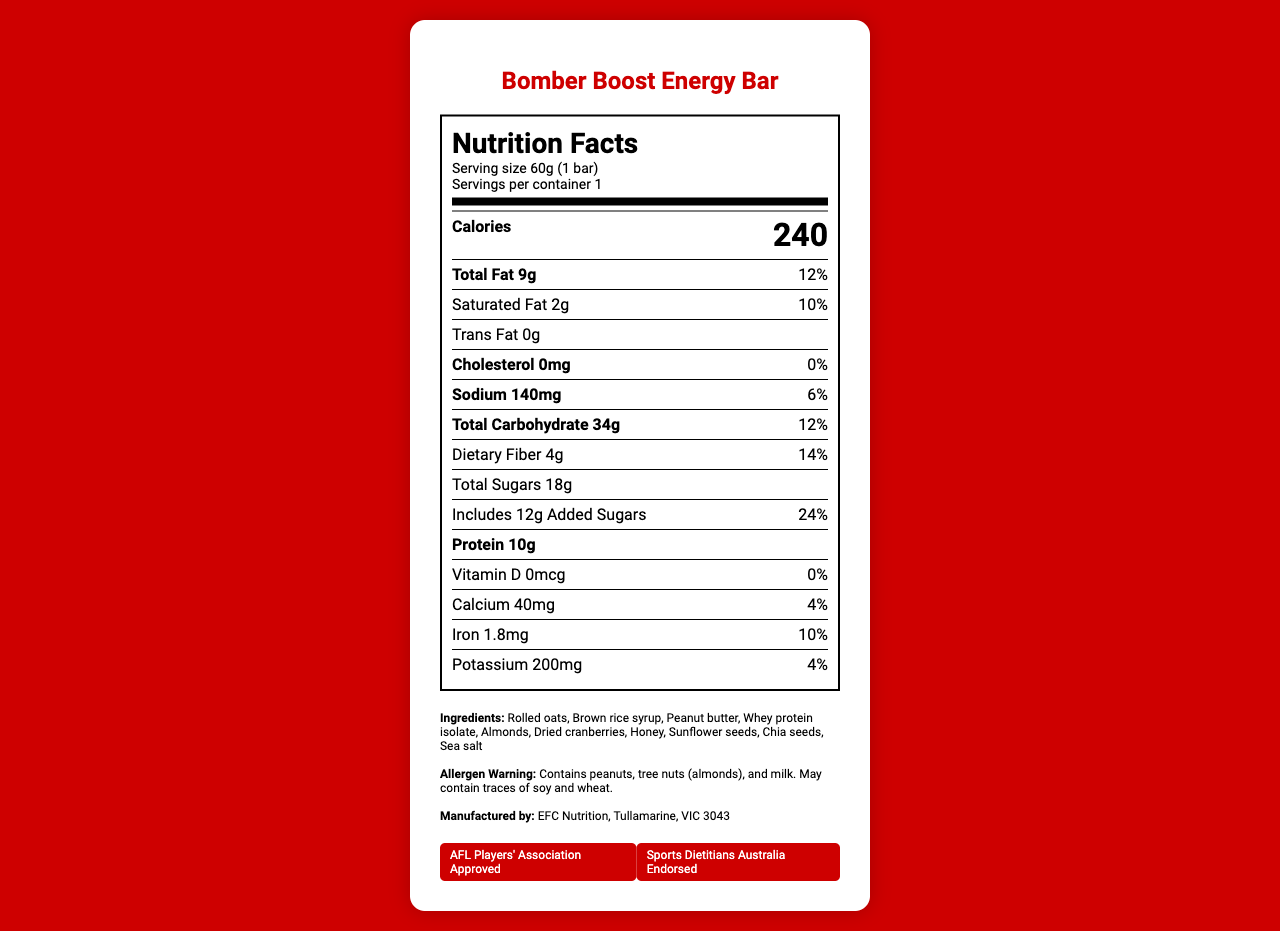What is the serving size of the Bomber Boost Energy Bar? The serving size is listed as 60g (1 bar) in the nutrition facts section.
Answer: 60g (1 bar) How many calories are there per serving of the Bomber Boost Energy Bar? The nutrition label states that there are 240 calories per serving.
Answer: 240 What is the total fat content per serving, and what percentage of the daily value does it represent? The label shows that the total fat content is 9 grams per serving, representing 12% of the daily value.
Answer: 9g, 12% What allergens are present in the Bomber Boost Energy Bar? The allergen warning section mentions that the product contains peanuts, tree nuts (almonds), and milk.
Answer: Peanuts, tree nuts (almonds), and milk How much protein is in one Bomber Boost Energy Bar? The nutrition facts section specifies that there are 10 grams of protein per serving.
Answer: 10g What is the amount of added sugars in one energy bar, and what percentage of the daily value does it include? The label states that there are 12 grams of added sugars, which is 24% of the daily value.
Answer: 12g, 24% Which of these certifications does the Bomber Boost Energy Bar have? A. Organic B. AFL Players' Association Approved C. Gluten-Free D. Vegan The document indicates that the product is AFL Players' Association Approved and Endorsed by Sports Dietitians Australia.
Answer: B What is the sodium content per serving? A. 120mg B. 130mg C. 140mg D. 150mg The nutrition label shows the sodium content as 140 mg per serving.
Answer: C Is the Bomber Boost Energy Bar developed in collaboration with a football club? The document states that it was developed in collaboration with Essendon Football Club's performance nutrition team.
Answer: Yes List two other common AFL energy bar brands mentioned in the document. The document lists Endura, Clif Bar, PowerBar, and Aussie Bodies as common AFL energy bar brands.
Answer: Endura, Clif Bar Summarize the contents of the document. The document contains detailed nutritional information for the Bomber Boost Energy Bar, including serving size, calorie content, macronutrient breakdown, and its vitamin and mineral content. It highlights its ingredients, allergens, and endorsements from reputable sports organizations.
Answer: The document is a comprehensive nutrition facts label for the Bomber Boost Energy Bar, detailing its serving size, calorie content, macronutrients, vitamins, minerals, and ingredients. It includes an allergen warning and information about its certifications and development in collaboration with the Essendon Football Club. What is the amount of Vitamin D in the Bomber Boost Energy Bar? The nutrition label indicates that there is 0 mcg of Vitamin D per serving.
Answer: 0mcg How many grams of dietary fiber are in one Bomber Boost Energy Bar? The nutrition facts section shows that there are 4 grams of dietary fiber per serving.
Answer: 4g Who manufactures the Bomber Boost Energy Bar? The document lists EFC Nutrition as the manufacturer, located in Tullamarine, VIC 3043.
Answer: EFC Nutrition, Tullamarine, VIC 3043 What percentage of the daily value of calcium does one Bomber Boost Energy Bar provide? The label states that the bar provides 4% of the daily value for calcium.
Answer: 4% What flavor varieties are available for the Bomber Boost Energy Bar? The document does not provide any information about different flavor varieties available for the energy bar.
Answer: Not enough information 